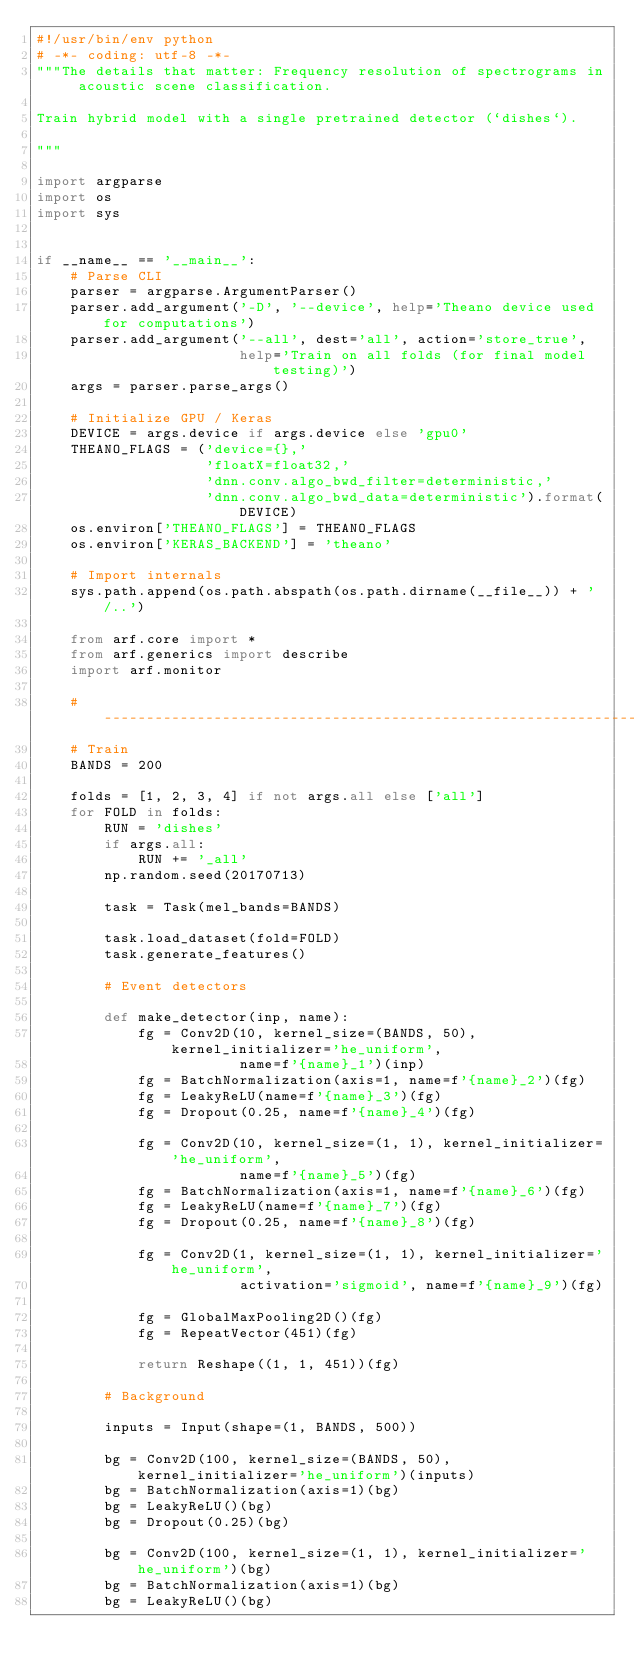<code> <loc_0><loc_0><loc_500><loc_500><_Python_>#!/usr/bin/env python
# -*- coding: utf-8 -*-
"""The details that matter: Frequency resolution of spectrograms in acoustic scene classification.

Train hybrid model with a single pretrained detector (`dishes`).

"""

import argparse
import os
import sys


if __name__ == '__main__':
    # Parse CLI
    parser = argparse.ArgumentParser()
    parser.add_argument('-D', '--device', help='Theano device used for computations')
    parser.add_argument('--all', dest='all', action='store_true',
                        help='Train on all folds (for final model testing)')
    args = parser.parse_args()

    # Initialize GPU / Keras
    DEVICE = args.device if args.device else 'gpu0'
    THEANO_FLAGS = ('device={},'
                    'floatX=float32,'
                    'dnn.conv.algo_bwd_filter=deterministic,'
                    'dnn.conv.algo_bwd_data=deterministic').format(DEVICE)
    os.environ['THEANO_FLAGS'] = THEANO_FLAGS
    os.environ['KERAS_BACKEND'] = 'theano'

    # Import internals
    sys.path.append(os.path.abspath(os.path.dirname(__file__)) + '/..')

    from arf.core import *
    from arf.generics import describe
    import arf.monitor

    # ----------------------------------------------------------------------
    # Train
    BANDS = 200

    folds = [1, 2, 3, 4] if not args.all else ['all']
    for FOLD in folds:
        RUN = 'dishes'
        if args.all:
            RUN += '_all'
        np.random.seed(20170713)

        task = Task(mel_bands=BANDS)

        task.load_dataset(fold=FOLD)
        task.generate_features()

        # Event detectors

        def make_detector(inp, name):
            fg = Conv2D(10, kernel_size=(BANDS, 50), kernel_initializer='he_uniform',
                        name=f'{name}_1')(inp)
            fg = BatchNormalization(axis=1, name=f'{name}_2')(fg)
            fg = LeakyReLU(name=f'{name}_3')(fg)
            fg = Dropout(0.25, name=f'{name}_4')(fg)

            fg = Conv2D(10, kernel_size=(1, 1), kernel_initializer='he_uniform',
                        name=f'{name}_5')(fg)
            fg = BatchNormalization(axis=1, name=f'{name}_6')(fg)
            fg = LeakyReLU(name=f'{name}_7')(fg)
            fg = Dropout(0.25, name=f'{name}_8')(fg)

            fg = Conv2D(1, kernel_size=(1, 1), kernel_initializer='he_uniform',
                        activation='sigmoid', name=f'{name}_9')(fg)

            fg = GlobalMaxPooling2D()(fg)
            fg = RepeatVector(451)(fg)

            return Reshape((1, 1, 451))(fg)

        # Background

        inputs = Input(shape=(1, BANDS, 500))

        bg = Conv2D(100, kernel_size=(BANDS, 50), kernel_initializer='he_uniform')(inputs)
        bg = BatchNormalization(axis=1)(bg)
        bg = LeakyReLU()(bg)
        bg = Dropout(0.25)(bg)

        bg = Conv2D(100, kernel_size=(1, 1), kernel_initializer='he_uniform')(bg)
        bg = BatchNormalization(axis=1)(bg)
        bg = LeakyReLU()(bg)</code> 